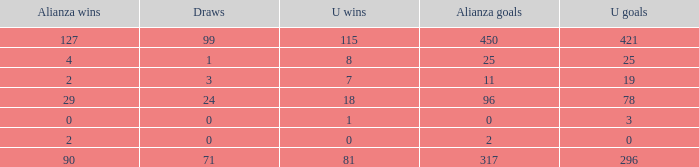What is the sum of Alianza Wins, when Alianza Goals is "317, and when U Goals is greater than 296? None. 